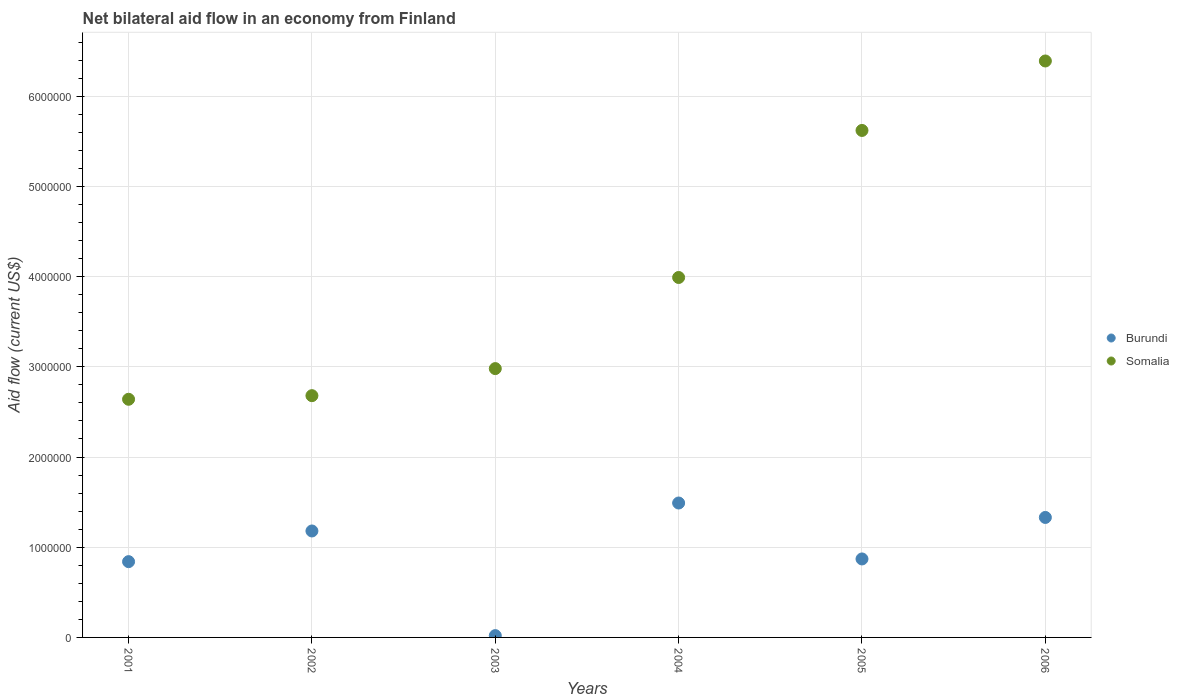How many different coloured dotlines are there?
Your answer should be very brief. 2. What is the net bilateral aid flow in Burundi in 2002?
Your response must be concise. 1.18e+06. Across all years, what is the maximum net bilateral aid flow in Somalia?
Provide a short and direct response. 6.39e+06. Across all years, what is the minimum net bilateral aid flow in Somalia?
Keep it short and to the point. 2.64e+06. What is the total net bilateral aid flow in Burundi in the graph?
Offer a very short reply. 5.73e+06. What is the difference between the net bilateral aid flow in Burundi in 2006 and the net bilateral aid flow in Somalia in 2005?
Keep it short and to the point. -4.29e+06. What is the average net bilateral aid flow in Somalia per year?
Your answer should be compact. 4.05e+06. In the year 2005, what is the difference between the net bilateral aid flow in Burundi and net bilateral aid flow in Somalia?
Make the answer very short. -4.75e+06. In how many years, is the net bilateral aid flow in Somalia greater than 1600000 US$?
Ensure brevity in your answer.  6. What is the ratio of the net bilateral aid flow in Somalia in 2003 to that in 2005?
Your response must be concise. 0.53. Is the difference between the net bilateral aid flow in Burundi in 2002 and 2005 greater than the difference between the net bilateral aid flow in Somalia in 2002 and 2005?
Provide a short and direct response. Yes. What is the difference between the highest and the second highest net bilateral aid flow in Burundi?
Your answer should be very brief. 1.60e+05. What is the difference between the highest and the lowest net bilateral aid flow in Somalia?
Ensure brevity in your answer.  3.75e+06. Is the sum of the net bilateral aid flow in Somalia in 2004 and 2005 greater than the maximum net bilateral aid flow in Burundi across all years?
Offer a terse response. Yes. Does the net bilateral aid flow in Somalia monotonically increase over the years?
Provide a succinct answer. Yes. Is the net bilateral aid flow in Somalia strictly greater than the net bilateral aid flow in Burundi over the years?
Make the answer very short. Yes. Is the net bilateral aid flow in Somalia strictly less than the net bilateral aid flow in Burundi over the years?
Keep it short and to the point. No. How many dotlines are there?
Give a very brief answer. 2. What is the difference between two consecutive major ticks on the Y-axis?
Make the answer very short. 1.00e+06. Does the graph contain any zero values?
Your answer should be compact. No. Where does the legend appear in the graph?
Ensure brevity in your answer.  Center right. How are the legend labels stacked?
Provide a succinct answer. Vertical. What is the title of the graph?
Offer a very short reply. Net bilateral aid flow in an economy from Finland. Does "Azerbaijan" appear as one of the legend labels in the graph?
Your answer should be compact. No. What is the label or title of the Y-axis?
Give a very brief answer. Aid flow (current US$). What is the Aid flow (current US$) in Burundi in 2001?
Your answer should be very brief. 8.40e+05. What is the Aid flow (current US$) in Somalia in 2001?
Offer a very short reply. 2.64e+06. What is the Aid flow (current US$) of Burundi in 2002?
Your answer should be very brief. 1.18e+06. What is the Aid flow (current US$) in Somalia in 2002?
Make the answer very short. 2.68e+06. What is the Aid flow (current US$) in Somalia in 2003?
Offer a terse response. 2.98e+06. What is the Aid flow (current US$) of Burundi in 2004?
Provide a short and direct response. 1.49e+06. What is the Aid flow (current US$) in Somalia in 2004?
Your answer should be very brief. 3.99e+06. What is the Aid flow (current US$) of Burundi in 2005?
Ensure brevity in your answer.  8.70e+05. What is the Aid flow (current US$) in Somalia in 2005?
Provide a succinct answer. 5.62e+06. What is the Aid flow (current US$) in Burundi in 2006?
Provide a short and direct response. 1.33e+06. What is the Aid flow (current US$) in Somalia in 2006?
Your answer should be compact. 6.39e+06. Across all years, what is the maximum Aid flow (current US$) in Burundi?
Make the answer very short. 1.49e+06. Across all years, what is the maximum Aid flow (current US$) of Somalia?
Offer a very short reply. 6.39e+06. Across all years, what is the minimum Aid flow (current US$) of Burundi?
Offer a very short reply. 2.00e+04. Across all years, what is the minimum Aid flow (current US$) in Somalia?
Provide a short and direct response. 2.64e+06. What is the total Aid flow (current US$) in Burundi in the graph?
Your response must be concise. 5.73e+06. What is the total Aid flow (current US$) of Somalia in the graph?
Give a very brief answer. 2.43e+07. What is the difference between the Aid flow (current US$) in Burundi in 2001 and that in 2002?
Provide a short and direct response. -3.40e+05. What is the difference between the Aid flow (current US$) in Burundi in 2001 and that in 2003?
Your response must be concise. 8.20e+05. What is the difference between the Aid flow (current US$) of Burundi in 2001 and that in 2004?
Keep it short and to the point. -6.50e+05. What is the difference between the Aid flow (current US$) in Somalia in 2001 and that in 2004?
Give a very brief answer. -1.35e+06. What is the difference between the Aid flow (current US$) in Burundi in 2001 and that in 2005?
Keep it short and to the point. -3.00e+04. What is the difference between the Aid flow (current US$) in Somalia in 2001 and that in 2005?
Your answer should be compact. -2.98e+06. What is the difference between the Aid flow (current US$) in Burundi in 2001 and that in 2006?
Keep it short and to the point. -4.90e+05. What is the difference between the Aid flow (current US$) of Somalia in 2001 and that in 2006?
Ensure brevity in your answer.  -3.75e+06. What is the difference between the Aid flow (current US$) of Burundi in 2002 and that in 2003?
Keep it short and to the point. 1.16e+06. What is the difference between the Aid flow (current US$) in Burundi in 2002 and that in 2004?
Keep it short and to the point. -3.10e+05. What is the difference between the Aid flow (current US$) of Somalia in 2002 and that in 2004?
Your answer should be compact. -1.31e+06. What is the difference between the Aid flow (current US$) of Somalia in 2002 and that in 2005?
Offer a terse response. -2.94e+06. What is the difference between the Aid flow (current US$) in Somalia in 2002 and that in 2006?
Your answer should be very brief. -3.71e+06. What is the difference between the Aid flow (current US$) in Burundi in 2003 and that in 2004?
Offer a terse response. -1.47e+06. What is the difference between the Aid flow (current US$) of Somalia in 2003 and that in 2004?
Offer a terse response. -1.01e+06. What is the difference between the Aid flow (current US$) of Burundi in 2003 and that in 2005?
Provide a succinct answer. -8.50e+05. What is the difference between the Aid flow (current US$) of Somalia in 2003 and that in 2005?
Give a very brief answer. -2.64e+06. What is the difference between the Aid flow (current US$) of Burundi in 2003 and that in 2006?
Offer a terse response. -1.31e+06. What is the difference between the Aid flow (current US$) of Somalia in 2003 and that in 2006?
Your answer should be very brief. -3.41e+06. What is the difference between the Aid flow (current US$) of Burundi in 2004 and that in 2005?
Keep it short and to the point. 6.20e+05. What is the difference between the Aid flow (current US$) in Somalia in 2004 and that in 2005?
Provide a succinct answer. -1.63e+06. What is the difference between the Aid flow (current US$) of Somalia in 2004 and that in 2006?
Offer a terse response. -2.40e+06. What is the difference between the Aid flow (current US$) of Burundi in 2005 and that in 2006?
Keep it short and to the point. -4.60e+05. What is the difference between the Aid flow (current US$) in Somalia in 2005 and that in 2006?
Provide a succinct answer. -7.70e+05. What is the difference between the Aid flow (current US$) in Burundi in 2001 and the Aid flow (current US$) in Somalia in 2002?
Ensure brevity in your answer.  -1.84e+06. What is the difference between the Aid flow (current US$) in Burundi in 2001 and the Aid flow (current US$) in Somalia in 2003?
Make the answer very short. -2.14e+06. What is the difference between the Aid flow (current US$) in Burundi in 2001 and the Aid flow (current US$) in Somalia in 2004?
Your response must be concise. -3.15e+06. What is the difference between the Aid flow (current US$) in Burundi in 2001 and the Aid flow (current US$) in Somalia in 2005?
Your answer should be very brief. -4.78e+06. What is the difference between the Aid flow (current US$) in Burundi in 2001 and the Aid flow (current US$) in Somalia in 2006?
Your answer should be compact. -5.55e+06. What is the difference between the Aid flow (current US$) of Burundi in 2002 and the Aid flow (current US$) of Somalia in 2003?
Provide a short and direct response. -1.80e+06. What is the difference between the Aid flow (current US$) of Burundi in 2002 and the Aid flow (current US$) of Somalia in 2004?
Keep it short and to the point. -2.81e+06. What is the difference between the Aid flow (current US$) in Burundi in 2002 and the Aid flow (current US$) in Somalia in 2005?
Offer a very short reply. -4.44e+06. What is the difference between the Aid flow (current US$) in Burundi in 2002 and the Aid flow (current US$) in Somalia in 2006?
Keep it short and to the point. -5.21e+06. What is the difference between the Aid flow (current US$) in Burundi in 2003 and the Aid flow (current US$) in Somalia in 2004?
Give a very brief answer. -3.97e+06. What is the difference between the Aid flow (current US$) in Burundi in 2003 and the Aid flow (current US$) in Somalia in 2005?
Give a very brief answer. -5.60e+06. What is the difference between the Aid flow (current US$) of Burundi in 2003 and the Aid flow (current US$) of Somalia in 2006?
Your response must be concise. -6.37e+06. What is the difference between the Aid flow (current US$) in Burundi in 2004 and the Aid flow (current US$) in Somalia in 2005?
Your answer should be compact. -4.13e+06. What is the difference between the Aid flow (current US$) of Burundi in 2004 and the Aid flow (current US$) of Somalia in 2006?
Offer a very short reply. -4.90e+06. What is the difference between the Aid flow (current US$) of Burundi in 2005 and the Aid flow (current US$) of Somalia in 2006?
Your response must be concise. -5.52e+06. What is the average Aid flow (current US$) of Burundi per year?
Provide a succinct answer. 9.55e+05. What is the average Aid flow (current US$) of Somalia per year?
Your answer should be very brief. 4.05e+06. In the year 2001, what is the difference between the Aid flow (current US$) of Burundi and Aid flow (current US$) of Somalia?
Provide a short and direct response. -1.80e+06. In the year 2002, what is the difference between the Aid flow (current US$) of Burundi and Aid flow (current US$) of Somalia?
Your response must be concise. -1.50e+06. In the year 2003, what is the difference between the Aid flow (current US$) in Burundi and Aid flow (current US$) in Somalia?
Your answer should be compact. -2.96e+06. In the year 2004, what is the difference between the Aid flow (current US$) of Burundi and Aid flow (current US$) of Somalia?
Your answer should be compact. -2.50e+06. In the year 2005, what is the difference between the Aid flow (current US$) of Burundi and Aid flow (current US$) of Somalia?
Offer a very short reply. -4.75e+06. In the year 2006, what is the difference between the Aid flow (current US$) of Burundi and Aid flow (current US$) of Somalia?
Your response must be concise. -5.06e+06. What is the ratio of the Aid flow (current US$) of Burundi in 2001 to that in 2002?
Offer a very short reply. 0.71. What is the ratio of the Aid flow (current US$) in Somalia in 2001 to that in 2002?
Offer a very short reply. 0.99. What is the ratio of the Aid flow (current US$) in Burundi in 2001 to that in 2003?
Offer a terse response. 42. What is the ratio of the Aid flow (current US$) of Somalia in 2001 to that in 2003?
Make the answer very short. 0.89. What is the ratio of the Aid flow (current US$) in Burundi in 2001 to that in 2004?
Make the answer very short. 0.56. What is the ratio of the Aid flow (current US$) in Somalia in 2001 to that in 2004?
Your response must be concise. 0.66. What is the ratio of the Aid flow (current US$) of Burundi in 2001 to that in 2005?
Offer a very short reply. 0.97. What is the ratio of the Aid flow (current US$) in Somalia in 2001 to that in 2005?
Your response must be concise. 0.47. What is the ratio of the Aid flow (current US$) of Burundi in 2001 to that in 2006?
Make the answer very short. 0.63. What is the ratio of the Aid flow (current US$) in Somalia in 2001 to that in 2006?
Keep it short and to the point. 0.41. What is the ratio of the Aid flow (current US$) in Burundi in 2002 to that in 2003?
Your answer should be compact. 59. What is the ratio of the Aid flow (current US$) in Somalia in 2002 to that in 2003?
Ensure brevity in your answer.  0.9. What is the ratio of the Aid flow (current US$) of Burundi in 2002 to that in 2004?
Give a very brief answer. 0.79. What is the ratio of the Aid flow (current US$) of Somalia in 2002 to that in 2004?
Make the answer very short. 0.67. What is the ratio of the Aid flow (current US$) of Burundi in 2002 to that in 2005?
Provide a short and direct response. 1.36. What is the ratio of the Aid flow (current US$) of Somalia in 2002 to that in 2005?
Ensure brevity in your answer.  0.48. What is the ratio of the Aid flow (current US$) in Burundi in 2002 to that in 2006?
Make the answer very short. 0.89. What is the ratio of the Aid flow (current US$) of Somalia in 2002 to that in 2006?
Provide a succinct answer. 0.42. What is the ratio of the Aid flow (current US$) in Burundi in 2003 to that in 2004?
Ensure brevity in your answer.  0.01. What is the ratio of the Aid flow (current US$) in Somalia in 2003 to that in 2004?
Give a very brief answer. 0.75. What is the ratio of the Aid flow (current US$) of Burundi in 2003 to that in 2005?
Make the answer very short. 0.02. What is the ratio of the Aid flow (current US$) in Somalia in 2003 to that in 2005?
Provide a succinct answer. 0.53. What is the ratio of the Aid flow (current US$) in Burundi in 2003 to that in 2006?
Give a very brief answer. 0.01. What is the ratio of the Aid flow (current US$) in Somalia in 2003 to that in 2006?
Keep it short and to the point. 0.47. What is the ratio of the Aid flow (current US$) of Burundi in 2004 to that in 2005?
Ensure brevity in your answer.  1.71. What is the ratio of the Aid flow (current US$) of Somalia in 2004 to that in 2005?
Provide a succinct answer. 0.71. What is the ratio of the Aid flow (current US$) of Burundi in 2004 to that in 2006?
Provide a succinct answer. 1.12. What is the ratio of the Aid flow (current US$) of Somalia in 2004 to that in 2006?
Keep it short and to the point. 0.62. What is the ratio of the Aid flow (current US$) of Burundi in 2005 to that in 2006?
Your response must be concise. 0.65. What is the ratio of the Aid flow (current US$) of Somalia in 2005 to that in 2006?
Give a very brief answer. 0.88. What is the difference between the highest and the second highest Aid flow (current US$) of Burundi?
Provide a succinct answer. 1.60e+05. What is the difference between the highest and the second highest Aid flow (current US$) of Somalia?
Make the answer very short. 7.70e+05. What is the difference between the highest and the lowest Aid flow (current US$) of Burundi?
Ensure brevity in your answer.  1.47e+06. What is the difference between the highest and the lowest Aid flow (current US$) of Somalia?
Give a very brief answer. 3.75e+06. 